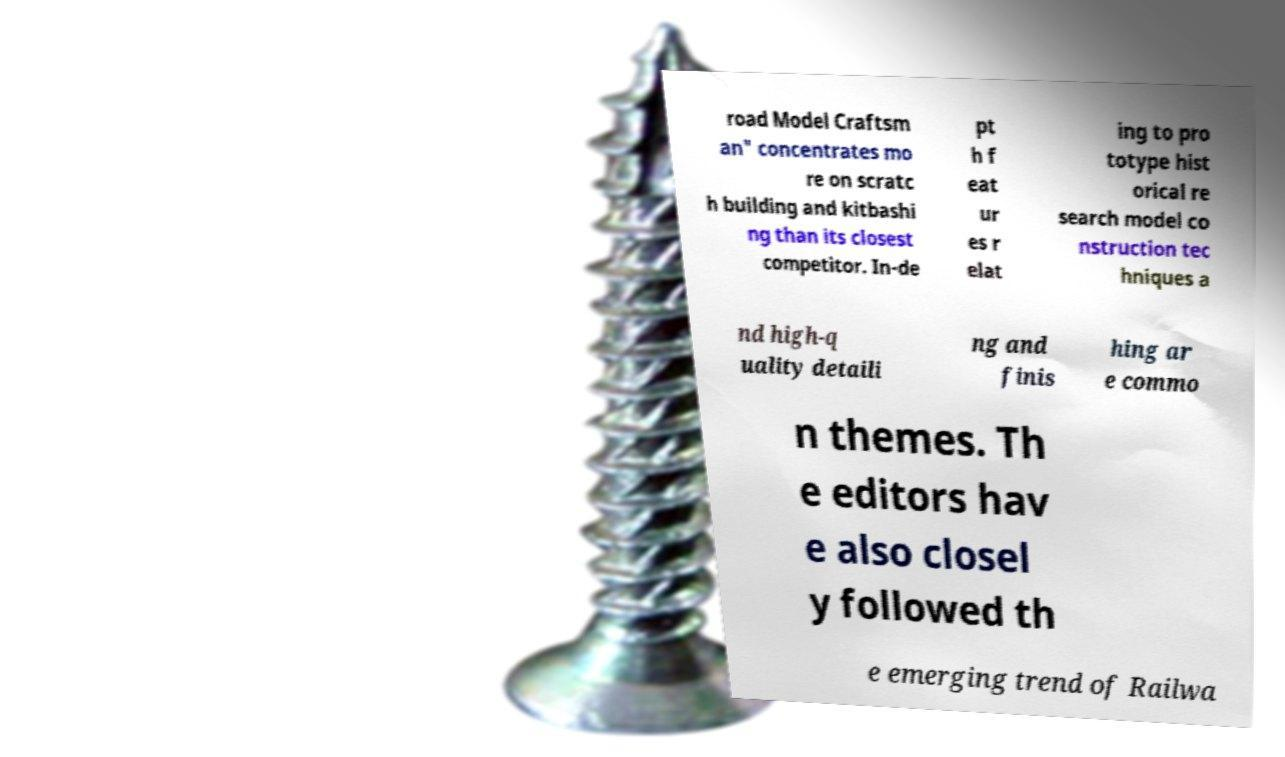For documentation purposes, I need the text within this image transcribed. Could you provide that? road Model Craftsm an" concentrates mo re on scratc h building and kitbashi ng than its closest competitor. In-de pt h f eat ur es r elat ing to pro totype hist orical re search model co nstruction tec hniques a nd high-q uality detaili ng and finis hing ar e commo n themes. Th e editors hav e also closel y followed th e emerging trend of Railwa 